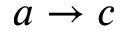Convert formula to latex. <formula><loc_0><loc_0><loc_500><loc_500>a \rightarrow c</formula> 